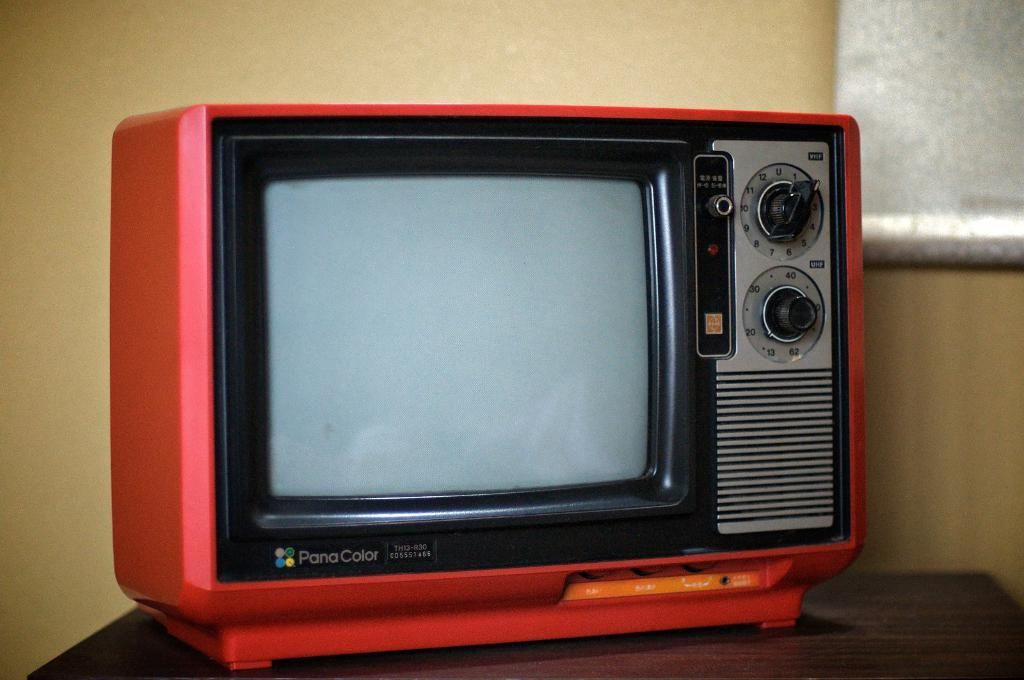<image>
Present a compact description of the photo's key features. A red Pana Color television sits on a table. 